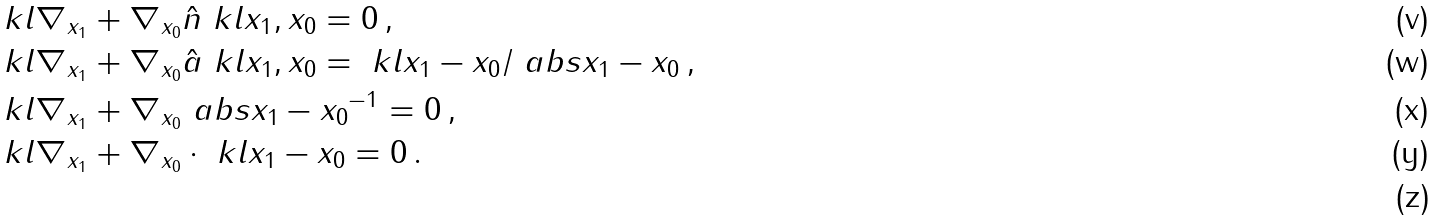Convert formula to latex. <formula><loc_0><loc_0><loc_500><loc_500>& \ k l { \nabla _ { x _ { 1 } } + \nabla _ { x _ { 0 } } } \hat { n } \ k l { x _ { 1 } , x _ { 0 } } = 0 \, , \\ & \ k l { \nabla _ { x _ { 1 } } + \nabla _ { x _ { 0 } } } \hat { a } \ k l { x _ { 1 } , x _ { 0 } } = \ k l { x _ { 1 } - x _ { 0 } } / \ a b s { x _ { 1 } - x _ { 0 } } \, , \\ & \ k l { \nabla _ { x _ { 1 } } + \nabla _ { x _ { 0 } } } \ a b s { x _ { 1 } - x _ { 0 } } ^ { - 1 } = 0 \, , \\ & \ k l { \nabla _ { x _ { 1 } } + \nabla _ { x _ { 0 } } } \cdot \ k l { x _ { 1 } - x _ { 0 } } = 0 \, . \\</formula> 